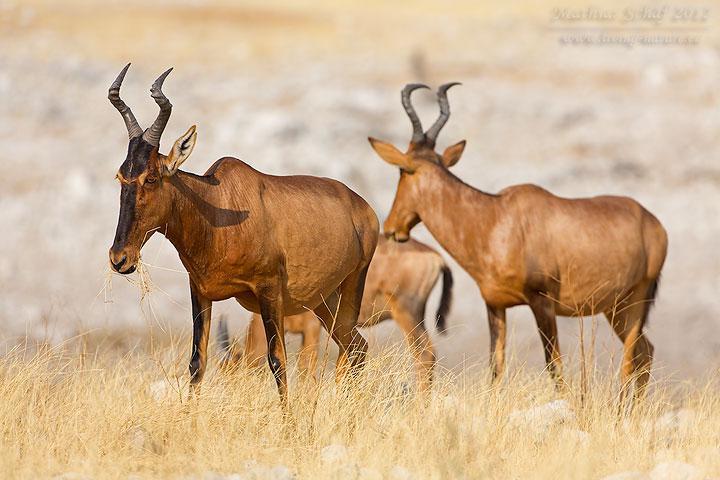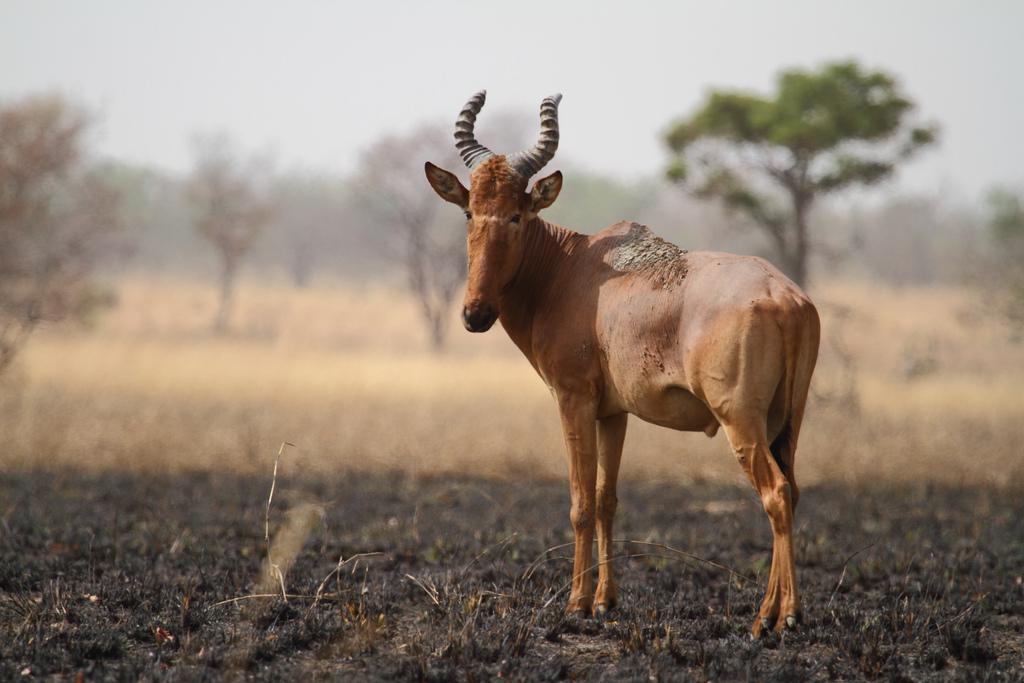The first image is the image on the left, the second image is the image on the right. Assess this claim about the two images: "there are two zebras in one of the images". Correct or not? Answer yes or no. No. The first image is the image on the left, the second image is the image on the right. For the images shown, is this caption "One image contains a zebra." true? Answer yes or no. No. 